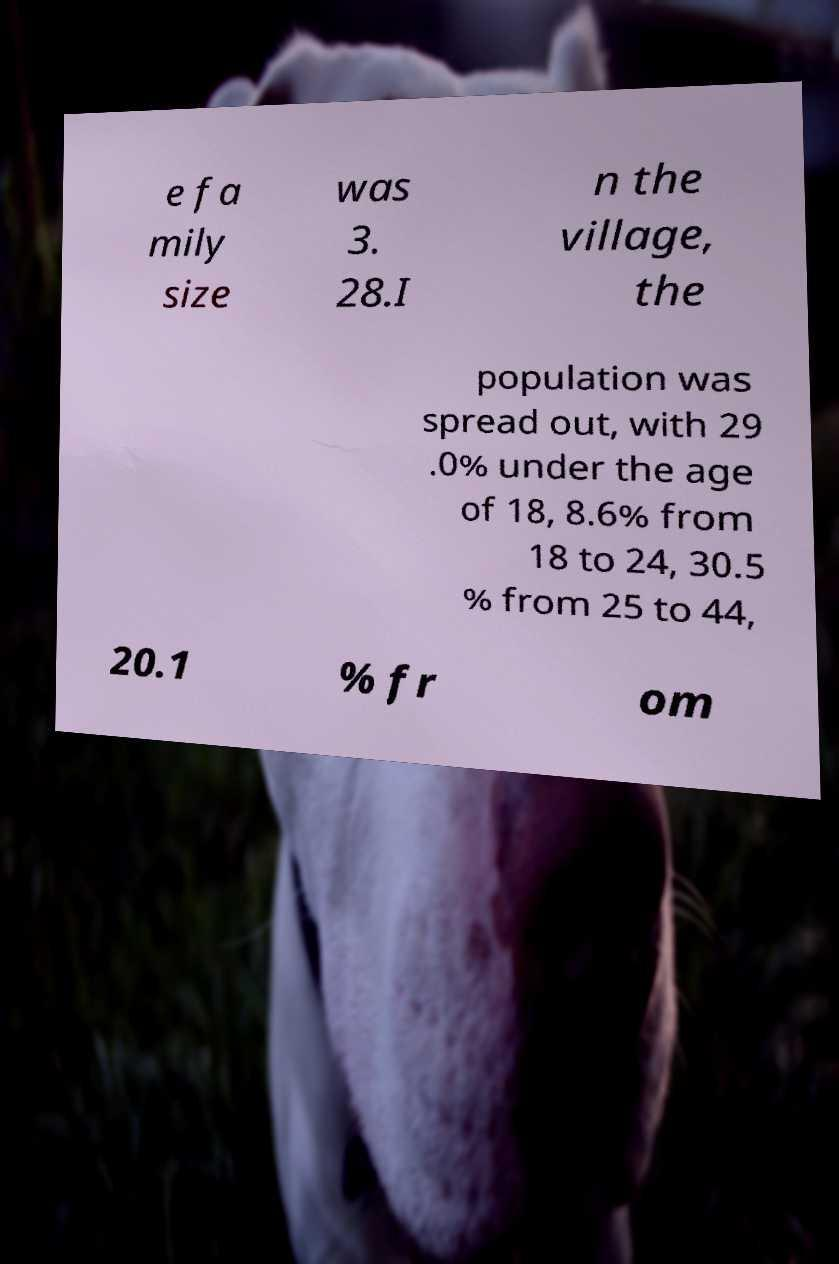I need the written content from this picture converted into text. Can you do that? e fa mily size was 3. 28.I n the village, the population was spread out, with 29 .0% under the age of 18, 8.6% from 18 to 24, 30.5 % from 25 to 44, 20.1 % fr om 